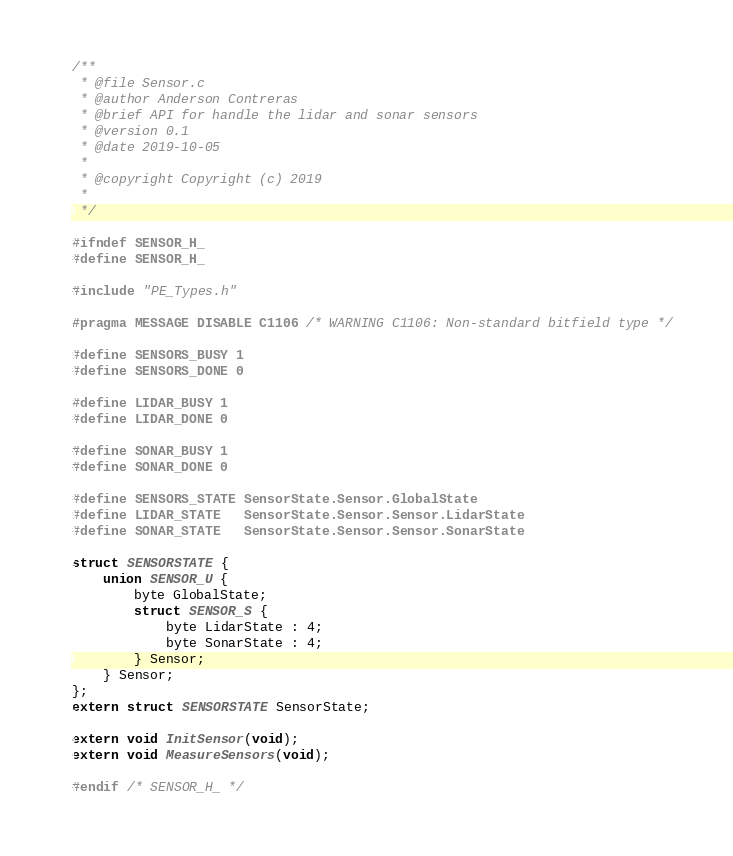Convert code to text. <code><loc_0><loc_0><loc_500><loc_500><_C_>/**
 * @file Sensor.c
 * @author Anderson Contreras
 * @brief API for handle the lidar and sonar sensors
 * @version 0.1
 * @date 2019-10-05
 *
 * @copyright Copyright (c) 2019
 *
 */

#ifndef SENSOR_H_
#define SENSOR_H_

#include "PE_Types.h"

#pragma MESSAGE DISABLE C1106 /* WARNING C1106: Non-standard bitfield type */

#define SENSORS_BUSY 1
#define SENSORS_DONE 0

#define LIDAR_BUSY 1
#define LIDAR_DONE 0

#define SONAR_BUSY 1
#define SONAR_DONE 0

#define SENSORS_STATE SensorState.Sensor.GlobalState
#define LIDAR_STATE   SensorState.Sensor.Sensor.LidarState
#define SONAR_STATE   SensorState.Sensor.Sensor.SonarState

struct SENSORSTATE {
    union SENSOR_U {
        byte GlobalState;
        struct SENSOR_S {
            byte LidarState : 4;
            byte SonarState : 4;
        } Sensor;
    } Sensor;
};
extern struct SENSORSTATE SensorState;

extern void InitSensor(void);
extern void MeasureSensors(void);

#endif /* SENSOR_H_ */
</code> 